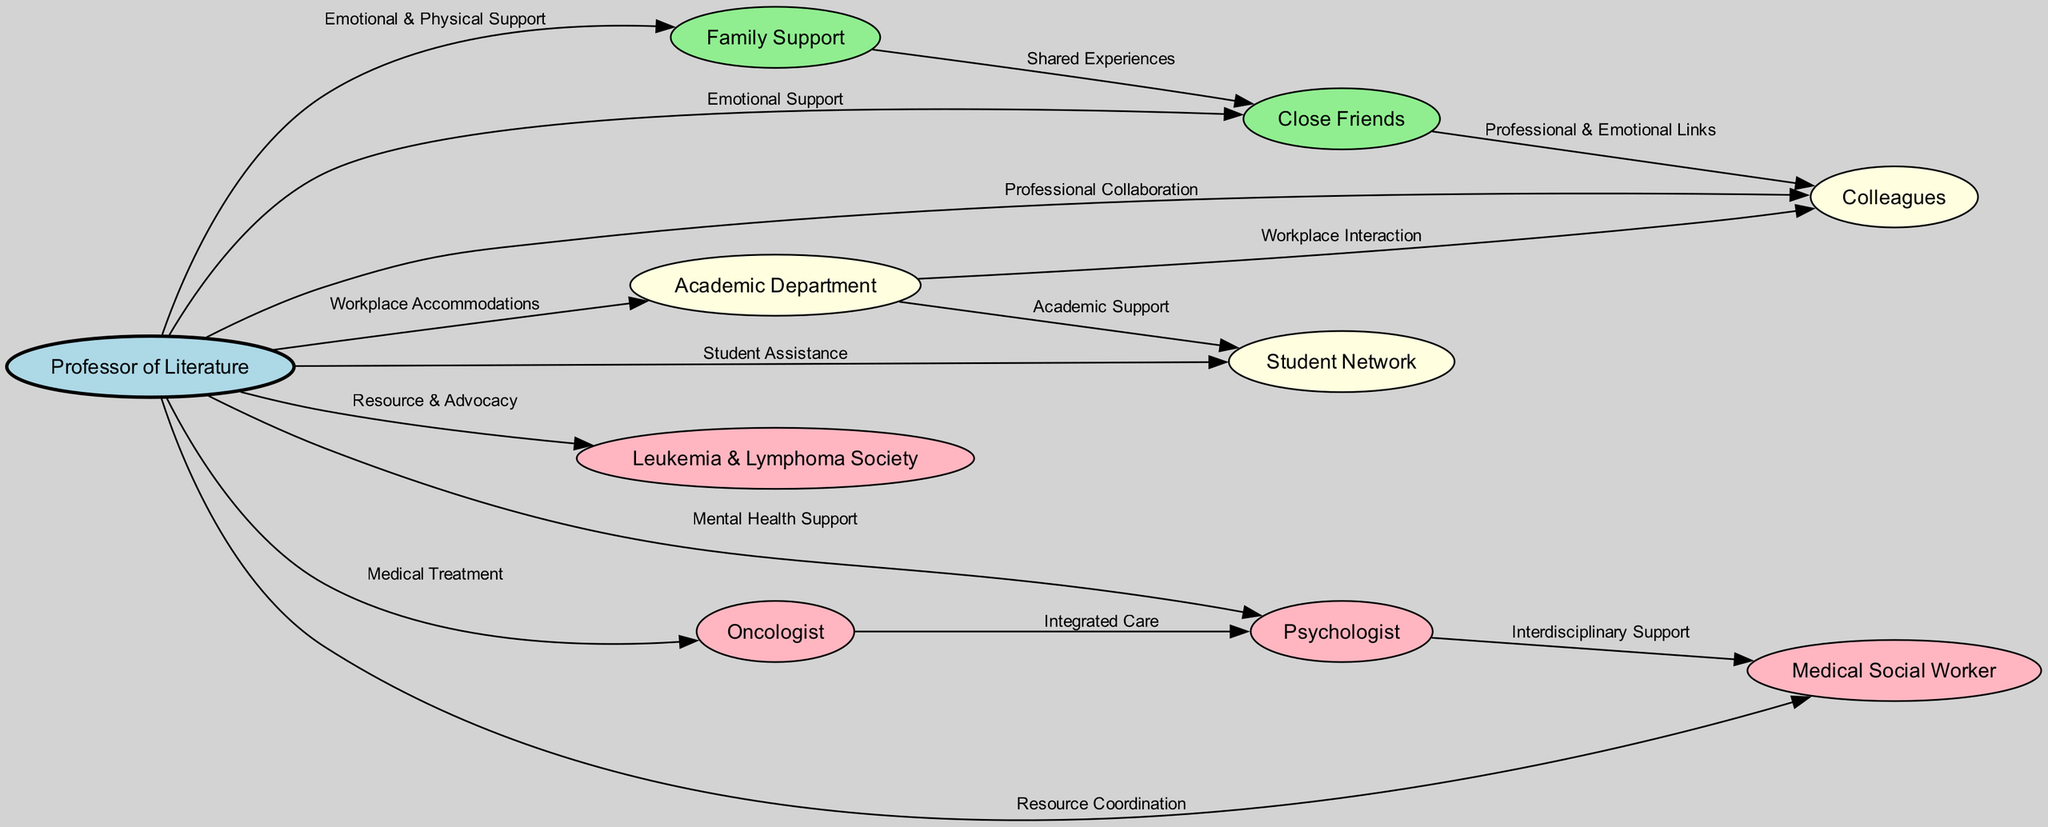What is the total number of nodes in the diagram? To find the total number of nodes, we can count all unique entities represented. The nodes are: Professor of Literature, Family Support, Close Friends, Colleagues, Academic Department, Student Network, Leukemia & Lymphoma Society, Psychologist, Oncologist, and Medical Social Worker. This gives us a total of 10 nodes.
Answer: 10 What type of support does the family provide to the professor? The diagram shows that the relationship between the professor and the family is labeled as "Emotional & Physical Support." This indicates the nature of the support provided.
Answer: Emotional & Physical Support How many edges connect the Professor of Literature to different support systems? The diagram illustrates ten relationships (edges) connecting the Professor of Literature to various systems of support such as family, close friends, and professionals. We can count each directed arrow originating from the professor.
Answer: 9 What is the role of the Psychologist in the diagram? The Psychologist is connected to the Professor of Literature with the label "Mental Health Support." Additionally, there is another connection from the Oncologist to the Psychologist labeled "Integrated Care," indicating that the psychologist plays a role in mental health as part of integrated care.
Answer: Mental Health Support Which two nodes have a direct relationship characterized by "Professional Collaboration"? The edge labeled "Professional Collaboration" specifically connects the Professor of Literature and the Colleagues, indicating a direct professional relationship characterized by collaboration.
Answer: Colleagues What type of support is indicated between the Oncologist and the Psychologist? The relationship between the Oncologist and the Psychologist is labeled as "Integrated Care." This suggests that their collaboration focuses on coordinating treatment and mental health support for managing chronic illness.
Answer: Integrated Care Which two nodes are connected through "Interdisciplinary Support"? The connection labeled "Interdisciplinary Support" indicates a relationship between the Psychologist and the Medical Social Worker. This suggests they work together as part of a team to provide comprehensive support.
Answer: Medical Social Worker How does the Academic Department interact with the Student Network? The diagram demonstrates that the Academic Department facilitates "Academic Support" to the Student Network, showcasing the role of the department in student success and assistance.
Answer: Academic Support What do the Close Friends and Family Support nodes share according to the diagram? The edge labeled "Shared Experiences" indicates a connection between Family Support and Close Friends, suggesting they have common experiences related to the professor's condition.
Answer: Shared Experiences 